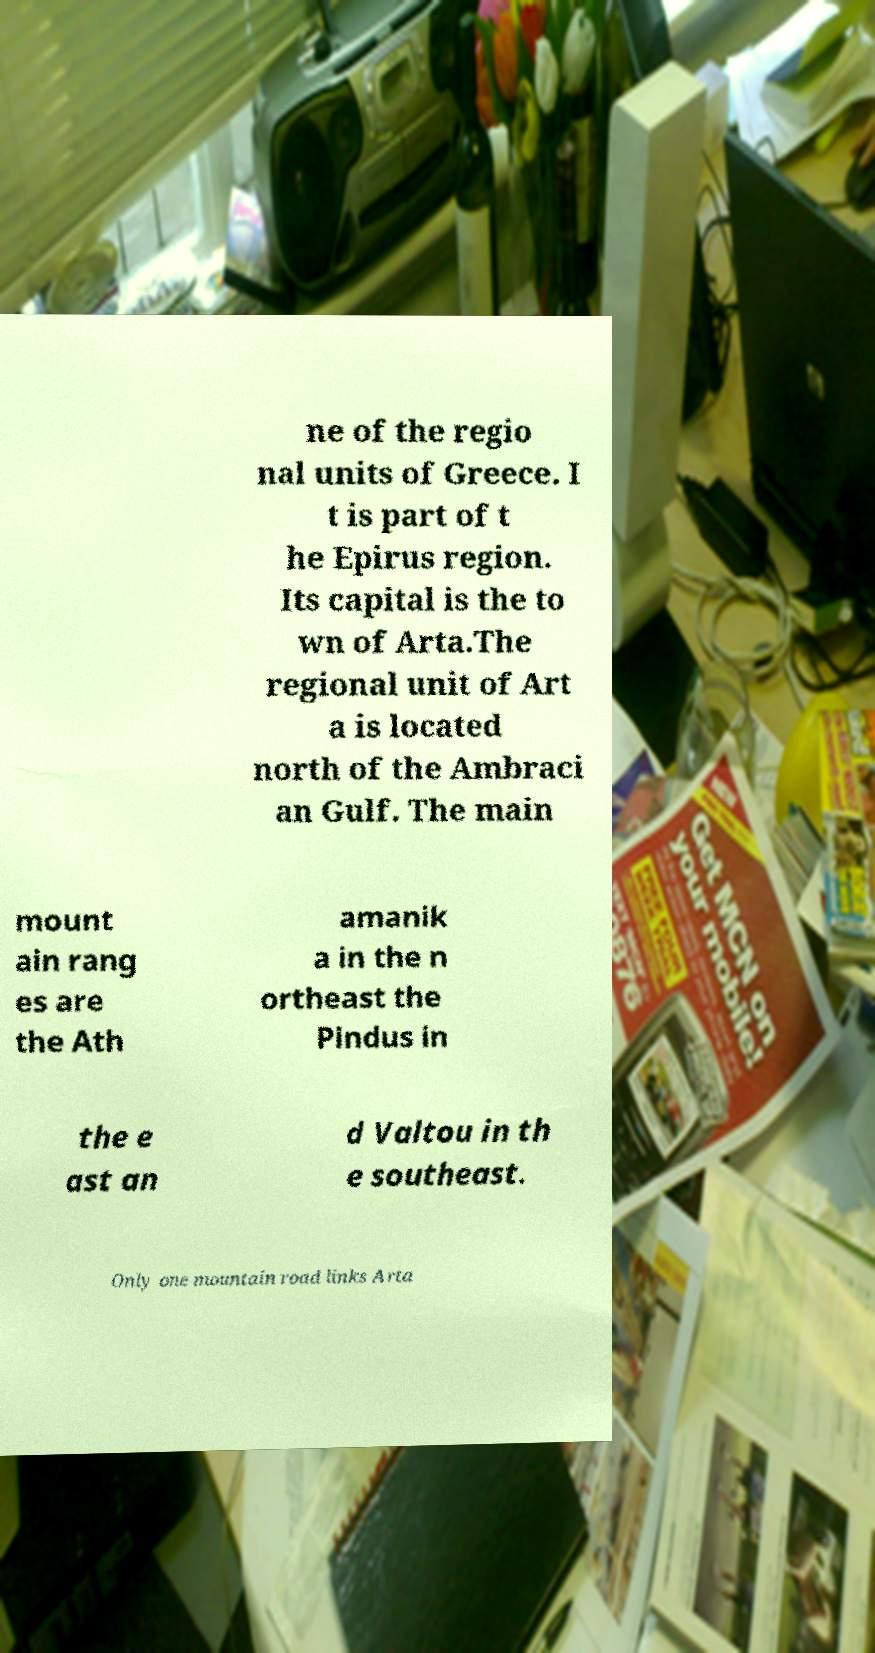Could you extract and type out the text from this image? ne of the regio nal units of Greece. I t is part of t he Epirus region. Its capital is the to wn of Arta.The regional unit of Art a is located north of the Ambraci an Gulf. The main mount ain rang es are the Ath amanik a in the n ortheast the Pindus in the e ast an d Valtou in th e southeast. Only one mountain road links Arta 